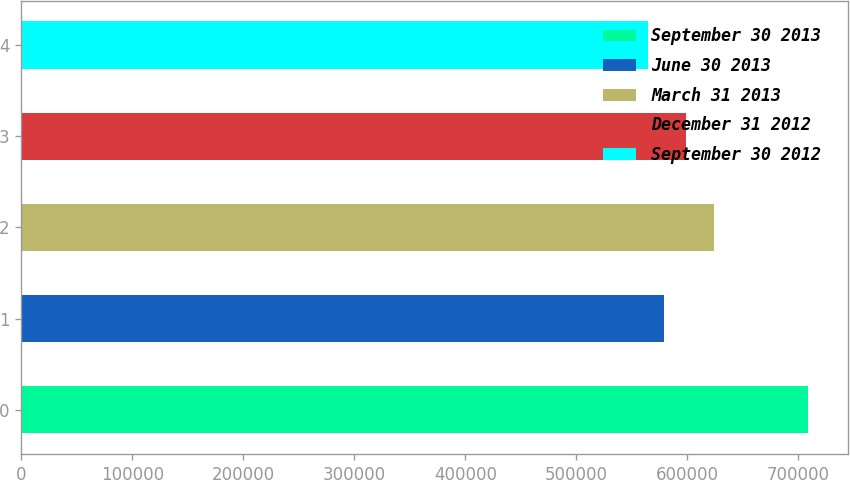Convert chart. <chart><loc_0><loc_0><loc_500><loc_500><bar_chart><fcel>September 30 2013<fcel>June 30 2013<fcel>March 31 2013<fcel>December 31 2012<fcel>September 30 2012<nl><fcel>709120<fcel>579426<fcel>623966<fcel>598579<fcel>565016<nl></chart> 